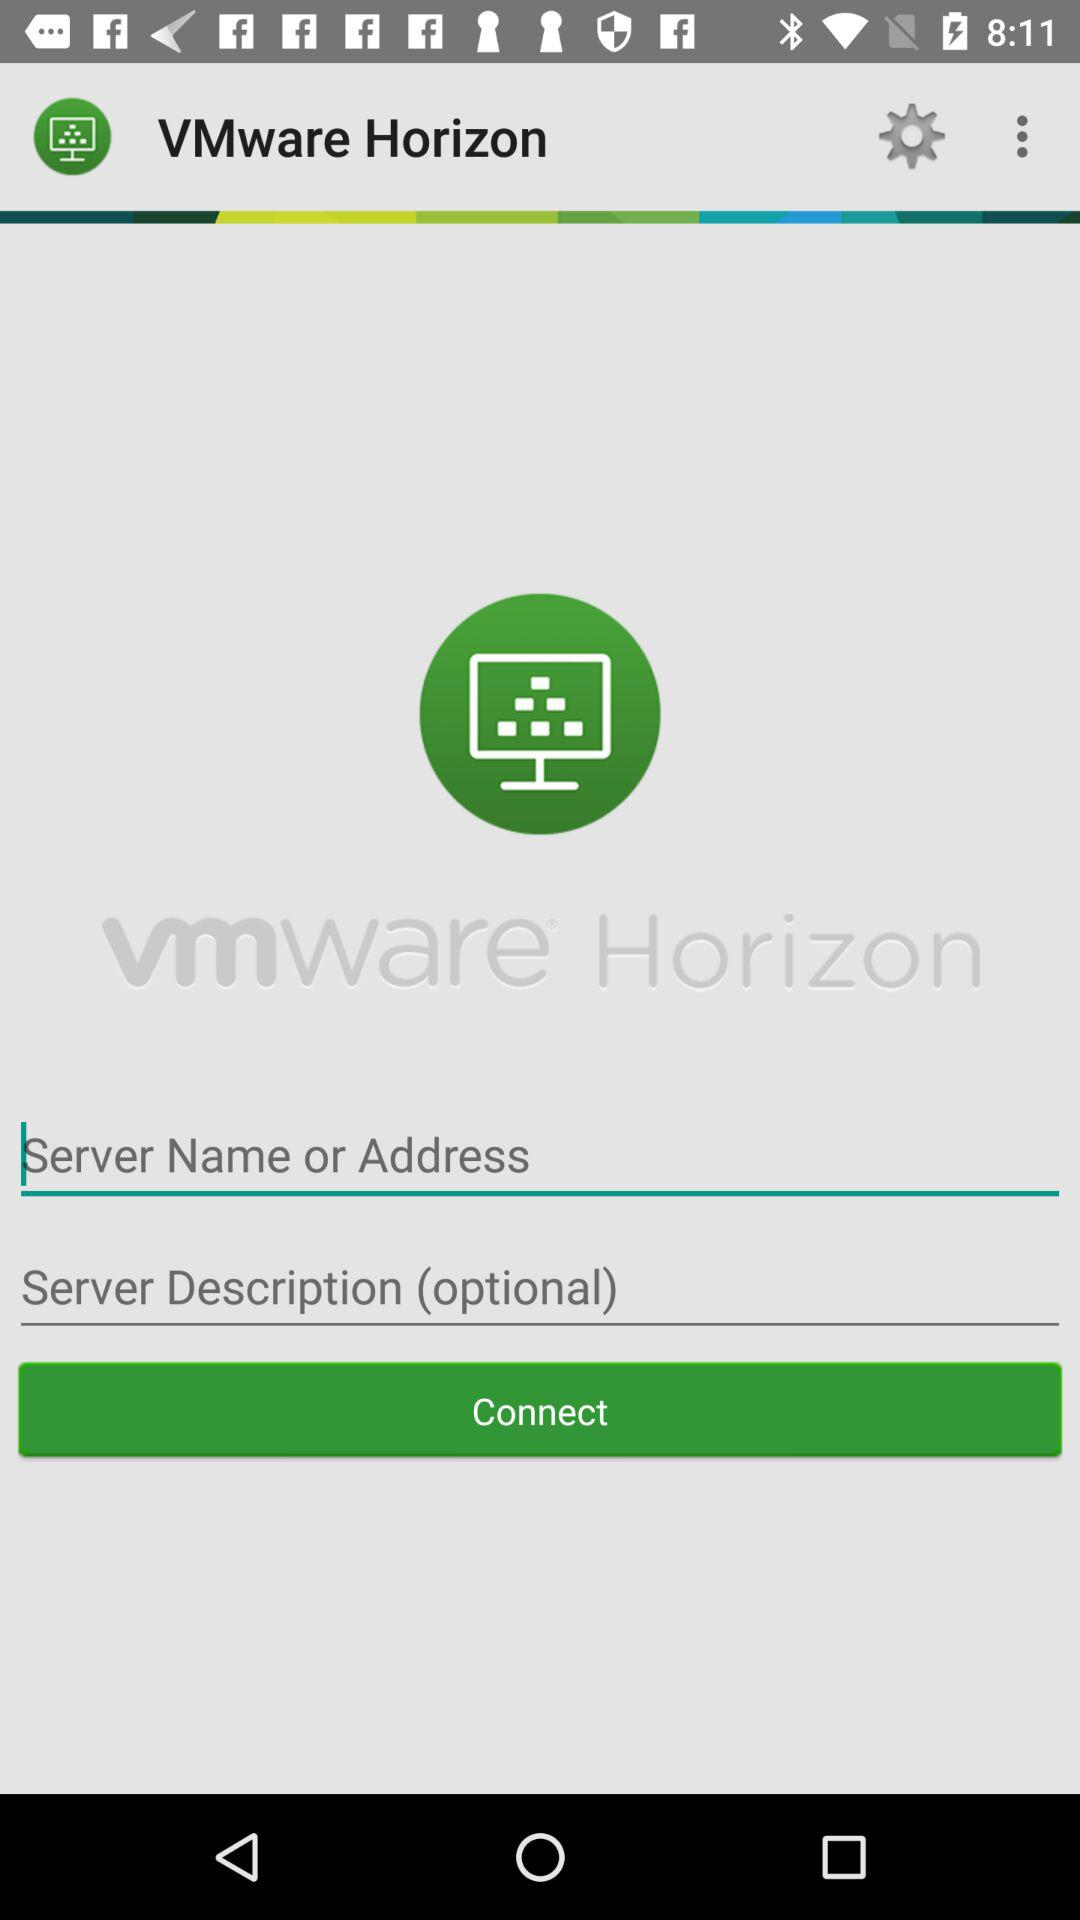What is the name of the application? The name of the application is "VMware Horizon". 